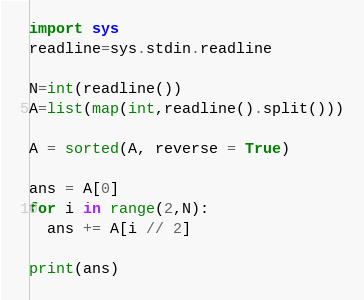Convert code to text. <code><loc_0><loc_0><loc_500><loc_500><_Python_>import sys
readline=sys.stdin.readline

N=int(readline())
A=list(map(int,readline().split()))

A = sorted(A, reverse = True)

ans = A[0]
for i in range(2,N):
  ans += A[i // 2]
  
print(ans)</code> 